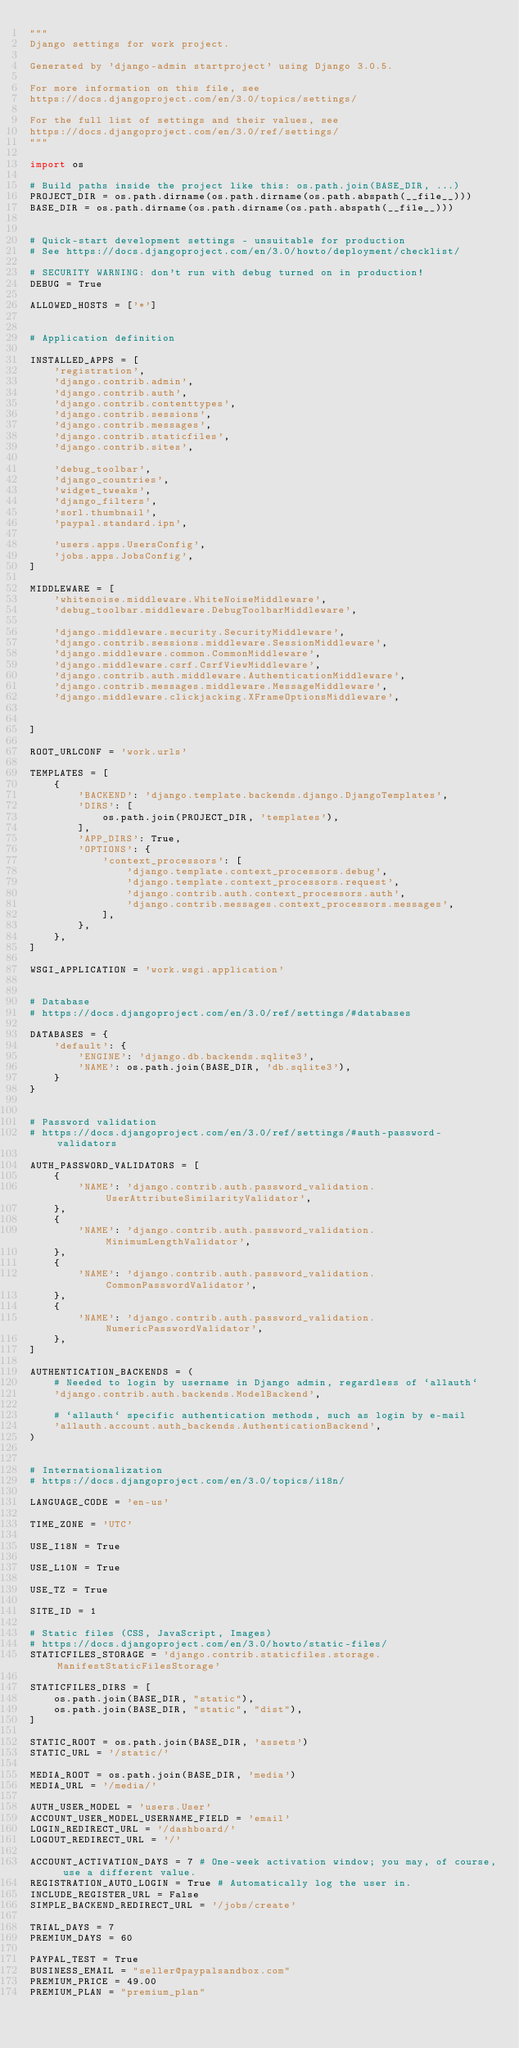<code> <loc_0><loc_0><loc_500><loc_500><_Python_>"""
Django settings for work project.

Generated by 'django-admin startproject' using Django 3.0.5.

For more information on this file, see
https://docs.djangoproject.com/en/3.0/topics/settings/

For the full list of settings and their values, see
https://docs.djangoproject.com/en/3.0/ref/settings/
"""

import os

# Build paths inside the project like this: os.path.join(BASE_DIR, ...)
PROJECT_DIR = os.path.dirname(os.path.dirname(os.path.abspath(__file__)))
BASE_DIR = os.path.dirname(os.path.dirname(os.path.abspath(__file__)))


# Quick-start development settings - unsuitable for production
# See https://docs.djangoproject.com/en/3.0/howto/deployment/checklist/

# SECURITY WARNING: don't run with debug turned on in production!
DEBUG = True

ALLOWED_HOSTS = ['*']


# Application definition

INSTALLED_APPS = [
    'registration',
    'django.contrib.admin',
    'django.contrib.auth',
    'django.contrib.contenttypes',
    'django.contrib.sessions',
    'django.contrib.messages',
    'django.contrib.staticfiles',
    'django.contrib.sites',

    'debug_toolbar',
    'django_countries',
    'widget_tweaks',
    'django_filters',
    'sorl.thumbnail',
    'paypal.standard.ipn',

    'users.apps.UsersConfig',
    'jobs.apps.JobsConfig',
]

MIDDLEWARE = [
    'whitenoise.middleware.WhiteNoiseMiddleware',
    'debug_toolbar.middleware.DebugToolbarMiddleware',

    'django.middleware.security.SecurityMiddleware',
    'django.contrib.sessions.middleware.SessionMiddleware',
    'django.middleware.common.CommonMiddleware',
    'django.middleware.csrf.CsrfViewMiddleware',
    'django.contrib.auth.middleware.AuthenticationMiddleware',
    'django.contrib.messages.middleware.MessageMiddleware',
    'django.middleware.clickjacking.XFrameOptionsMiddleware',
    
    
]

ROOT_URLCONF = 'work.urls'

TEMPLATES = [
    {
        'BACKEND': 'django.template.backends.django.DjangoTemplates',
        'DIRS': [
            os.path.join(PROJECT_DIR, 'templates'),
        ],
        'APP_DIRS': True,
        'OPTIONS': {
            'context_processors': [
                'django.template.context_processors.debug',
                'django.template.context_processors.request',
                'django.contrib.auth.context_processors.auth',
                'django.contrib.messages.context_processors.messages',
            ],
        },
    },
]

WSGI_APPLICATION = 'work.wsgi.application'


# Database
# https://docs.djangoproject.com/en/3.0/ref/settings/#databases

DATABASES = {
    'default': {
        'ENGINE': 'django.db.backends.sqlite3',
        'NAME': os.path.join(BASE_DIR, 'db.sqlite3'),
    }
}


# Password validation
# https://docs.djangoproject.com/en/3.0/ref/settings/#auth-password-validators

AUTH_PASSWORD_VALIDATORS = [
    {
        'NAME': 'django.contrib.auth.password_validation.UserAttributeSimilarityValidator',
    },
    {
        'NAME': 'django.contrib.auth.password_validation.MinimumLengthValidator',
    },
    {
        'NAME': 'django.contrib.auth.password_validation.CommonPasswordValidator',
    },
    {
        'NAME': 'django.contrib.auth.password_validation.NumericPasswordValidator',
    },
]

AUTHENTICATION_BACKENDS = (
    # Needed to login by username in Django admin, regardless of `allauth`
    'django.contrib.auth.backends.ModelBackend',

    # `allauth` specific authentication methods, such as login by e-mail
    'allauth.account.auth_backends.AuthenticationBackend',
)


# Internationalization
# https://docs.djangoproject.com/en/3.0/topics/i18n/

LANGUAGE_CODE = 'en-us'

TIME_ZONE = 'UTC'

USE_I18N = True

USE_L10N = True

USE_TZ = True

SITE_ID = 1

# Static files (CSS, JavaScript, Images)
# https://docs.djangoproject.com/en/3.0/howto/static-files/
STATICFILES_STORAGE = 'django.contrib.staticfiles.storage.ManifestStaticFilesStorage'

STATICFILES_DIRS = [
    os.path.join(BASE_DIR, "static"),
    os.path.join(BASE_DIR, "static", "dist"),
]

STATIC_ROOT = os.path.join(BASE_DIR, 'assets')
STATIC_URL = '/static/'

MEDIA_ROOT = os.path.join(BASE_DIR, 'media')
MEDIA_URL = '/media/'

AUTH_USER_MODEL = 'users.User'
ACCOUNT_USER_MODEL_USERNAME_FIELD = 'email'
LOGIN_REDIRECT_URL = '/dashboard/'
LOGOUT_REDIRECT_URL = '/'

ACCOUNT_ACTIVATION_DAYS = 7 # One-week activation window; you may, of course, use a different value.
REGISTRATION_AUTO_LOGIN = True # Automatically log the user in.
INCLUDE_REGISTER_URL = False
SIMPLE_BACKEND_REDIRECT_URL = '/jobs/create'

TRIAL_DAYS = 7
PREMIUM_DAYS = 60

PAYPAL_TEST = True
BUSINESS_EMAIL = "seller@paypalsandbox.com"
PREMIUM_PRICE = 49.00
PREMIUM_PLAN = "premium_plan"
</code> 